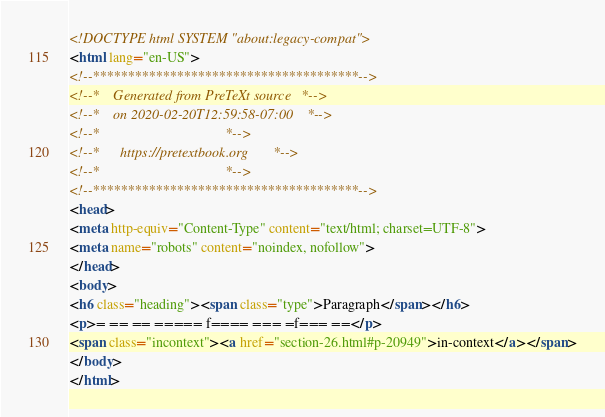<code> <loc_0><loc_0><loc_500><loc_500><_HTML_><!DOCTYPE html SYSTEM "about:legacy-compat">
<html lang="en-US">
<!--**************************************-->
<!--*    Generated from PreTeXt source   *-->
<!--*    on 2020-02-20T12:59:58-07:00    *-->
<!--*                                    *-->
<!--*      https://pretextbook.org       *-->
<!--*                                    *-->
<!--**************************************-->
<head>
<meta http-equiv="Content-Type" content="text/html; charset=UTF-8">
<meta name="robots" content="noindex, nofollow">
</head>
<body>
<h6 class="heading"><span class="type">Paragraph</span></h6>
<p>= == == ===== f==== === =f=== ==</p>
<span class="incontext"><a href="section-26.html#p-20949">in-context</a></span>
</body>
</html>
</code> 